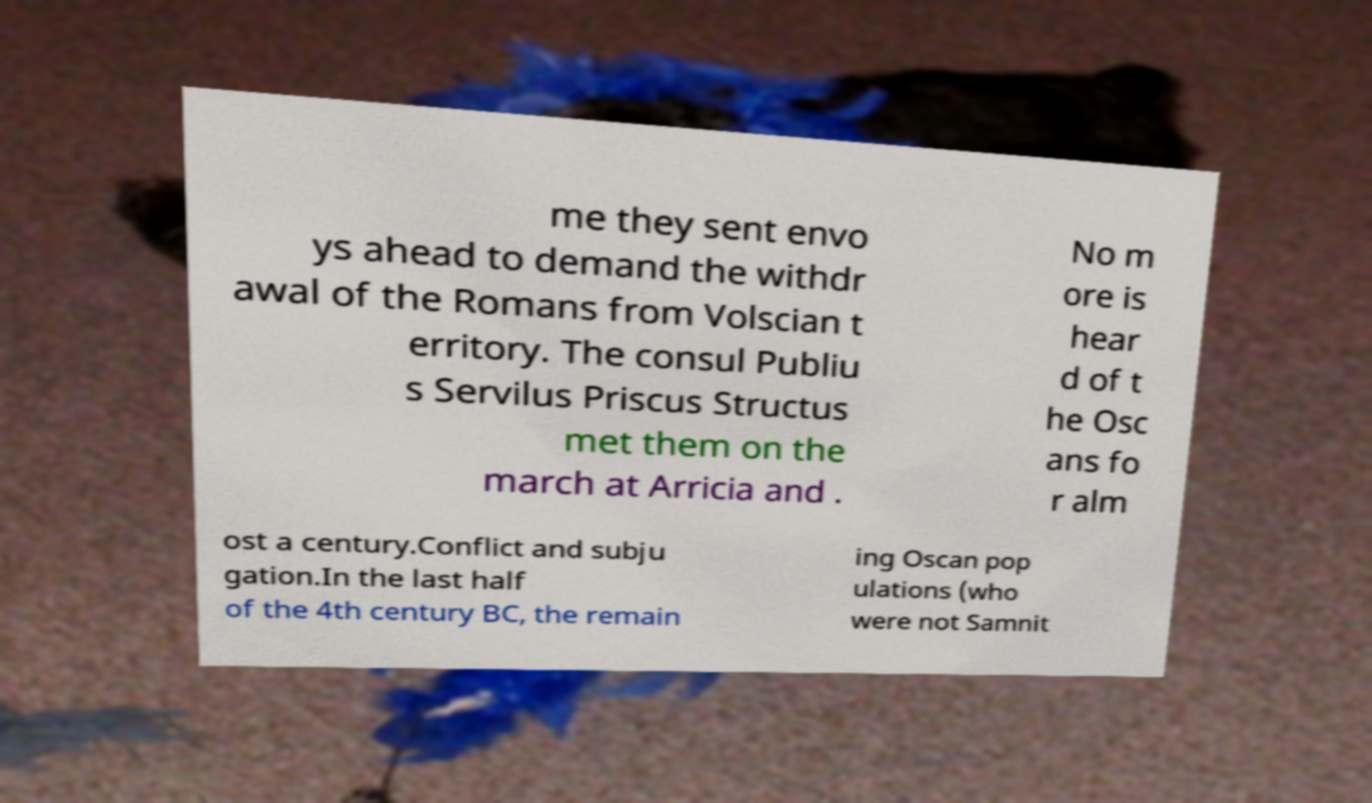Can you read and provide the text displayed in the image?This photo seems to have some interesting text. Can you extract and type it out for me? me they sent envo ys ahead to demand the withdr awal of the Romans from Volscian t erritory. The consul Publiu s Servilus Priscus Structus met them on the march at Arricia and . No m ore is hear d of t he Osc ans fo r alm ost a century.Conflict and subju gation.In the last half of the 4th century BC, the remain ing Oscan pop ulations (who were not Samnit 